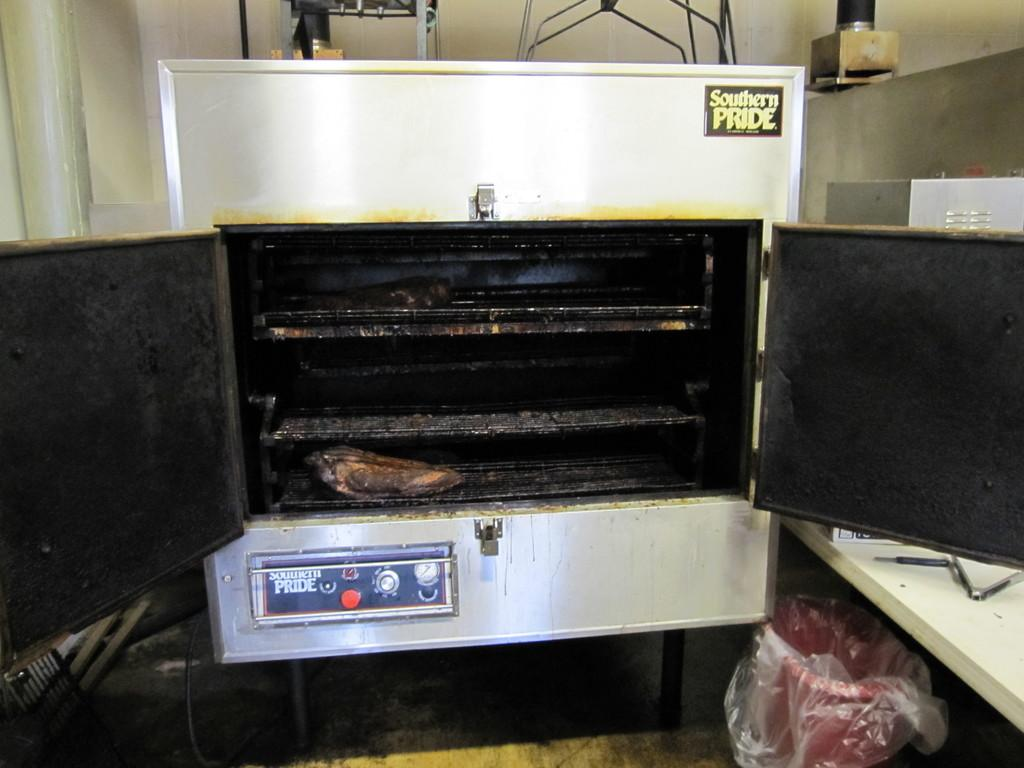Provide a one-sentence caption for the provided image. An oven that has southern pride on it. 